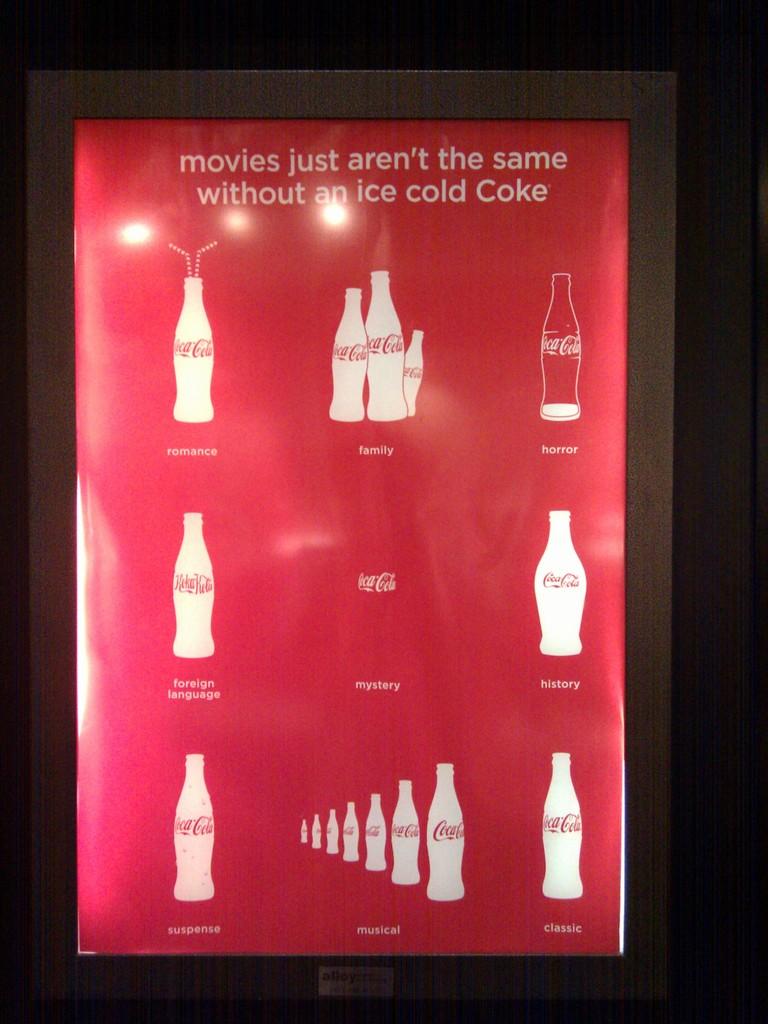What genre is in the top left hand corner?
Provide a succinct answer. Romance. 